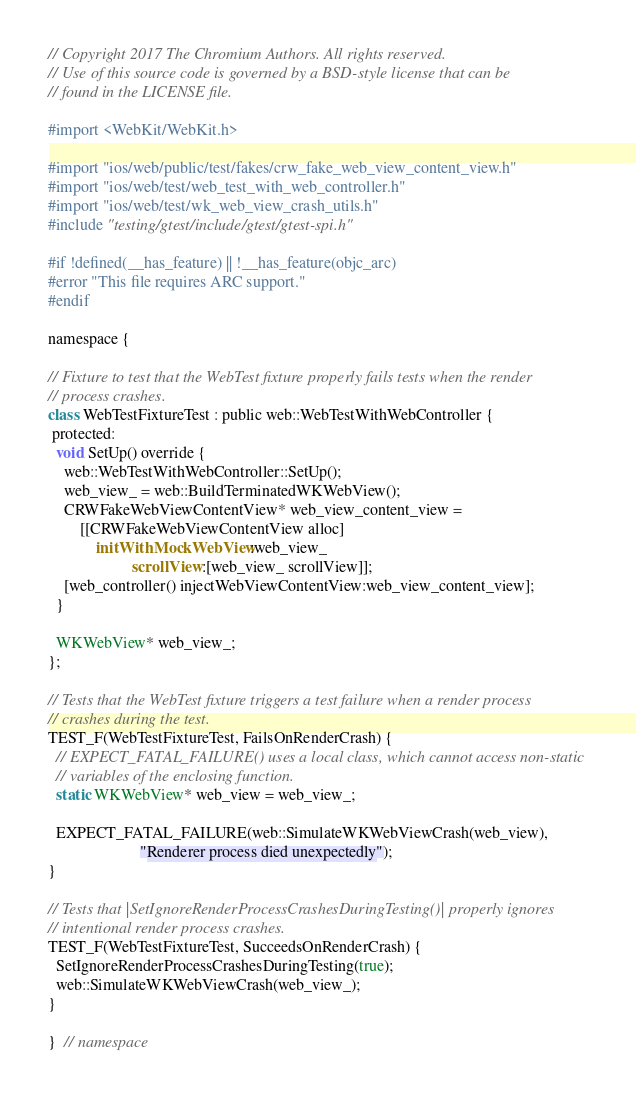Convert code to text. <code><loc_0><loc_0><loc_500><loc_500><_ObjectiveC_>// Copyright 2017 The Chromium Authors. All rights reserved.
// Use of this source code is governed by a BSD-style license that can be
// found in the LICENSE file.

#import <WebKit/WebKit.h>

#import "ios/web/public/test/fakes/crw_fake_web_view_content_view.h"
#import "ios/web/test/web_test_with_web_controller.h"
#import "ios/web/test/wk_web_view_crash_utils.h"
#include "testing/gtest/include/gtest/gtest-spi.h"

#if !defined(__has_feature) || !__has_feature(objc_arc)
#error "This file requires ARC support."
#endif

namespace {

// Fixture to test that the WebTest fixture properly fails tests when the render
// process crashes.
class WebTestFixtureTest : public web::WebTestWithWebController {
 protected:
  void SetUp() override {
    web::WebTestWithWebController::SetUp();
    web_view_ = web::BuildTerminatedWKWebView();
    CRWFakeWebViewContentView* web_view_content_view =
        [[CRWFakeWebViewContentView alloc]
            initWithMockWebView:web_view_
                     scrollView:[web_view_ scrollView]];
    [web_controller() injectWebViewContentView:web_view_content_view];
  }

  WKWebView* web_view_;
};

// Tests that the WebTest fixture triggers a test failure when a render process
// crashes during the test.
TEST_F(WebTestFixtureTest, FailsOnRenderCrash) {
  // EXPECT_FATAL_FAILURE() uses a local class, which cannot access non-static
  // variables of the enclosing function.
  static WKWebView* web_view = web_view_;

  EXPECT_FATAL_FAILURE(web::SimulateWKWebViewCrash(web_view),
                       "Renderer process died unexpectedly");
}

// Tests that |SetIgnoreRenderProcessCrashesDuringTesting()| properly ignores
// intentional render process crashes.
TEST_F(WebTestFixtureTest, SucceedsOnRenderCrash) {
  SetIgnoreRenderProcessCrashesDuringTesting(true);
  web::SimulateWKWebViewCrash(web_view_);
}

}  // namespace
</code> 